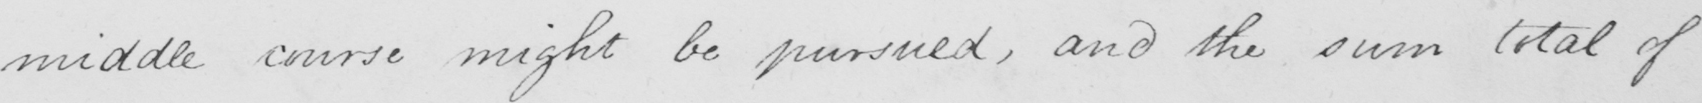What text is written in this handwritten line? a middle course might be pursued , and the sum total of 